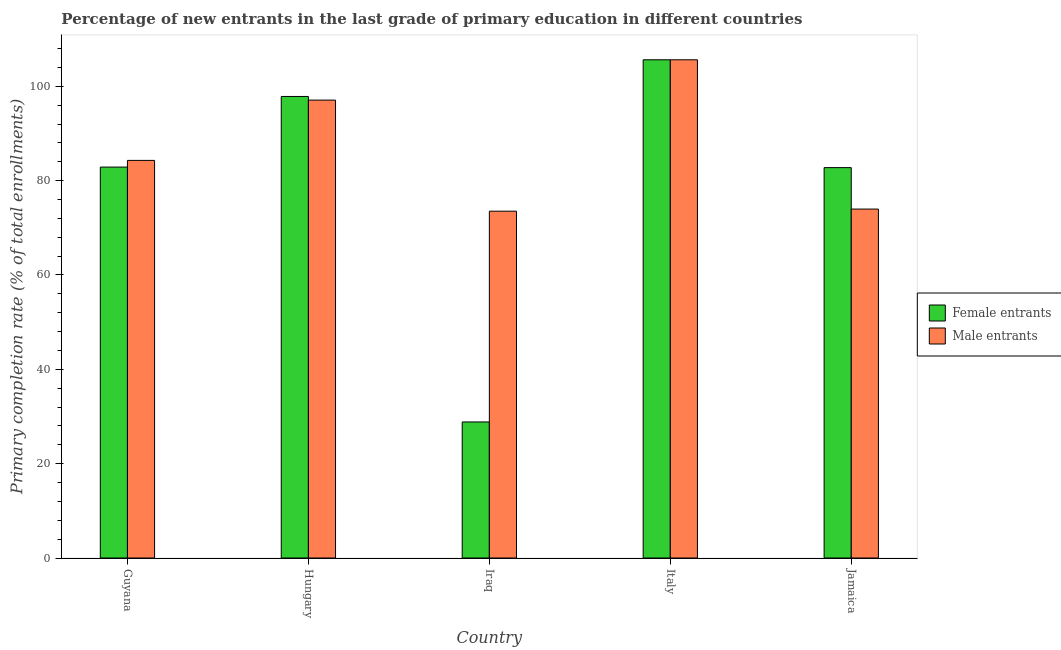How many different coloured bars are there?
Offer a terse response. 2. How many groups of bars are there?
Ensure brevity in your answer.  5. Are the number of bars per tick equal to the number of legend labels?
Offer a very short reply. Yes. Are the number of bars on each tick of the X-axis equal?
Provide a succinct answer. Yes. How many bars are there on the 5th tick from the left?
Make the answer very short. 2. How many bars are there on the 1st tick from the right?
Ensure brevity in your answer.  2. What is the label of the 3rd group of bars from the left?
Provide a succinct answer. Iraq. What is the primary completion rate of male entrants in Hungary?
Your answer should be very brief. 97.07. Across all countries, what is the maximum primary completion rate of male entrants?
Your answer should be very brief. 105.61. Across all countries, what is the minimum primary completion rate of female entrants?
Offer a very short reply. 28.84. In which country was the primary completion rate of female entrants maximum?
Your answer should be very brief. Italy. In which country was the primary completion rate of male entrants minimum?
Keep it short and to the point. Iraq. What is the total primary completion rate of female entrants in the graph?
Your answer should be compact. 397.92. What is the difference between the primary completion rate of female entrants in Hungary and that in Iraq?
Provide a succinct answer. 69. What is the difference between the primary completion rate of female entrants in Hungary and the primary completion rate of male entrants in Jamaica?
Keep it short and to the point. 23.87. What is the average primary completion rate of male entrants per country?
Provide a succinct answer. 86.89. What is the difference between the primary completion rate of male entrants and primary completion rate of female entrants in Hungary?
Keep it short and to the point. -0.77. What is the ratio of the primary completion rate of female entrants in Iraq to that in Jamaica?
Ensure brevity in your answer.  0.35. Is the primary completion rate of male entrants in Hungary less than that in Iraq?
Ensure brevity in your answer.  No. What is the difference between the highest and the second highest primary completion rate of female entrants?
Offer a terse response. 7.77. What is the difference between the highest and the lowest primary completion rate of female entrants?
Offer a very short reply. 76.78. In how many countries, is the primary completion rate of male entrants greater than the average primary completion rate of male entrants taken over all countries?
Offer a terse response. 2. Is the sum of the primary completion rate of female entrants in Iraq and Jamaica greater than the maximum primary completion rate of male entrants across all countries?
Offer a terse response. Yes. What does the 2nd bar from the left in Jamaica represents?
Give a very brief answer. Male entrants. What does the 1st bar from the right in Hungary represents?
Offer a very short reply. Male entrants. What is the difference between two consecutive major ticks on the Y-axis?
Offer a terse response. 20. Are the values on the major ticks of Y-axis written in scientific E-notation?
Offer a terse response. No. Does the graph contain any zero values?
Your answer should be very brief. No. Does the graph contain grids?
Offer a terse response. No. How are the legend labels stacked?
Offer a very short reply. Vertical. What is the title of the graph?
Your answer should be very brief. Percentage of new entrants in the last grade of primary education in different countries. Does "By country of asylum" appear as one of the legend labels in the graph?
Your response must be concise. No. What is the label or title of the X-axis?
Provide a short and direct response. Country. What is the label or title of the Y-axis?
Ensure brevity in your answer.  Primary completion rate (% of total enrollments). What is the Primary completion rate (% of total enrollments) of Female entrants in Guyana?
Provide a succinct answer. 82.87. What is the Primary completion rate (% of total enrollments) in Male entrants in Guyana?
Ensure brevity in your answer.  84.29. What is the Primary completion rate (% of total enrollments) of Female entrants in Hungary?
Make the answer very short. 97.84. What is the Primary completion rate (% of total enrollments) of Male entrants in Hungary?
Provide a succinct answer. 97.07. What is the Primary completion rate (% of total enrollments) of Female entrants in Iraq?
Offer a very short reply. 28.84. What is the Primary completion rate (% of total enrollments) in Male entrants in Iraq?
Offer a terse response. 73.52. What is the Primary completion rate (% of total enrollments) in Female entrants in Italy?
Your answer should be compact. 105.61. What is the Primary completion rate (% of total enrollments) of Male entrants in Italy?
Provide a short and direct response. 105.61. What is the Primary completion rate (% of total enrollments) of Female entrants in Jamaica?
Provide a short and direct response. 82.76. What is the Primary completion rate (% of total enrollments) of Male entrants in Jamaica?
Make the answer very short. 73.97. Across all countries, what is the maximum Primary completion rate (% of total enrollments) of Female entrants?
Your response must be concise. 105.61. Across all countries, what is the maximum Primary completion rate (% of total enrollments) of Male entrants?
Give a very brief answer. 105.61. Across all countries, what is the minimum Primary completion rate (% of total enrollments) of Female entrants?
Give a very brief answer. 28.84. Across all countries, what is the minimum Primary completion rate (% of total enrollments) in Male entrants?
Ensure brevity in your answer.  73.52. What is the total Primary completion rate (% of total enrollments) in Female entrants in the graph?
Give a very brief answer. 397.92. What is the total Primary completion rate (% of total enrollments) of Male entrants in the graph?
Make the answer very short. 434.46. What is the difference between the Primary completion rate (% of total enrollments) of Female entrants in Guyana and that in Hungary?
Offer a very short reply. -14.97. What is the difference between the Primary completion rate (% of total enrollments) of Male entrants in Guyana and that in Hungary?
Keep it short and to the point. -12.78. What is the difference between the Primary completion rate (% of total enrollments) in Female entrants in Guyana and that in Iraq?
Your answer should be very brief. 54.03. What is the difference between the Primary completion rate (% of total enrollments) of Male entrants in Guyana and that in Iraq?
Provide a short and direct response. 10.76. What is the difference between the Primary completion rate (% of total enrollments) of Female entrants in Guyana and that in Italy?
Keep it short and to the point. -22.75. What is the difference between the Primary completion rate (% of total enrollments) in Male entrants in Guyana and that in Italy?
Your answer should be compact. -21.33. What is the difference between the Primary completion rate (% of total enrollments) of Female entrants in Guyana and that in Jamaica?
Offer a terse response. 0.11. What is the difference between the Primary completion rate (% of total enrollments) of Male entrants in Guyana and that in Jamaica?
Give a very brief answer. 10.32. What is the difference between the Primary completion rate (% of total enrollments) in Female entrants in Hungary and that in Iraq?
Provide a short and direct response. 69. What is the difference between the Primary completion rate (% of total enrollments) in Male entrants in Hungary and that in Iraq?
Offer a terse response. 23.55. What is the difference between the Primary completion rate (% of total enrollments) of Female entrants in Hungary and that in Italy?
Your answer should be very brief. -7.77. What is the difference between the Primary completion rate (% of total enrollments) in Male entrants in Hungary and that in Italy?
Offer a very short reply. -8.54. What is the difference between the Primary completion rate (% of total enrollments) of Female entrants in Hungary and that in Jamaica?
Your answer should be very brief. 15.09. What is the difference between the Primary completion rate (% of total enrollments) in Male entrants in Hungary and that in Jamaica?
Your response must be concise. 23.1. What is the difference between the Primary completion rate (% of total enrollments) of Female entrants in Iraq and that in Italy?
Give a very brief answer. -76.78. What is the difference between the Primary completion rate (% of total enrollments) in Male entrants in Iraq and that in Italy?
Provide a short and direct response. -32.09. What is the difference between the Primary completion rate (% of total enrollments) in Female entrants in Iraq and that in Jamaica?
Your answer should be very brief. -53.92. What is the difference between the Primary completion rate (% of total enrollments) in Male entrants in Iraq and that in Jamaica?
Provide a short and direct response. -0.45. What is the difference between the Primary completion rate (% of total enrollments) in Female entrants in Italy and that in Jamaica?
Your response must be concise. 22.86. What is the difference between the Primary completion rate (% of total enrollments) of Male entrants in Italy and that in Jamaica?
Offer a terse response. 31.64. What is the difference between the Primary completion rate (% of total enrollments) of Female entrants in Guyana and the Primary completion rate (% of total enrollments) of Male entrants in Hungary?
Make the answer very short. -14.2. What is the difference between the Primary completion rate (% of total enrollments) of Female entrants in Guyana and the Primary completion rate (% of total enrollments) of Male entrants in Iraq?
Offer a very short reply. 9.35. What is the difference between the Primary completion rate (% of total enrollments) in Female entrants in Guyana and the Primary completion rate (% of total enrollments) in Male entrants in Italy?
Provide a succinct answer. -22.74. What is the difference between the Primary completion rate (% of total enrollments) of Female entrants in Guyana and the Primary completion rate (% of total enrollments) of Male entrants in Jamaica?
Your response must be concise. 8.9. What is the difference between the Primary completion rate (% of total enrollments) of Female entrants in Hungary and the Primary completion rate (% of total enrollments) of Male entrants in Iraq?
Offer a very short reply. 24.32. What is the difference between the Primary completion rate (% of total enrollments) in Female entrants in Hungary and the Primary completion rate (% of total enrollments) in Male entrants in Italy?
Ensure brevity in your answer.  -7.77. What is the difference between the Primary completion rate (% of total enrollments) in Female entrants in Hungary and the Primary completion rate (% of total enrollments) in Male entrants in Jamaica?
Make the answer very short. 23.87. What is the difference between the Primary completion rate (% of total enrollments) of Female entrants in Iraq and the Primary completion rate (% of total enrollments) of Male entrants in Italy?
Give a very brief answer. -76.77. What is the difference between the Primary completion rate (% of total enrollments) in Female entrants in Iraq and the Primary completion rate (% of total enrollments) in Male entrants in Jamaica?
Provide a short and direct response. -45.13. What is the difference between the Primary completion rate (% of total enrollments) of Female entrants in Italy and the Primary completion rate (% of total enrollments) of Male entrants in Jamaica?
Provide a succinct answer. 31.65. What is the average Primary completion rate (% of total enrollments) of Female entrants per country?
Offer a terse response. 79.58. What is the average Primary completion rate (% of total enrollments) in Male entrants per country?
Your answer should be very brief. 86.89. What is the difference between the Primary completion rate (% of total enrollments) of Female entrants and Primary completion rate (% of total enrollments) of Male entrants in Guyana?
Your answer should be compact. -1.42. What is the difference between the Primary completion rate (% of total enrollments) of Female entrants and Primary completion rate (% of total enrollments) of Male entrants in Hungary?
Keep it short and to the point. 0.77. What is the difference between the Primary completion rate (% of total enrollments) in Female entrants and Primary completion rate (% of total enrollments) in Male entrants in Iraq?
Your response must be concise. -44.68. What is the difference between the Primary completion rate (% of total enrollments) of Female entrants and Primary completion rate (% of total enrollments) of Male entrants in Italy?
Your answer should be very brief. 0. What is the difference between the Primary completion rate (% of total enrollments) in Female entrants and Primary completion rate (% of total enrollments) in Male entrants in Jamaica?
Provide a short and direct response. 8.79. What is the ratio of the Primary completion rate (% of total enrollments) in Female entrants in Guyana to that in Hungary?
Your answer should be very brief. 0.85. What is the ratio of the Primary completion rate (% of total enrollments) of Male entrants in Guyana to that in Hungary?
Offer a terse response. 0.87. What is the ratio of the Primary completion rate (% of total enrollments) in Female entrants in Guyana to that in Iraq?
Provide a succinct answer. 2.87. What is the ratio of the Primary completion rate (% of total enrollments) of Male entrants in Guyana to that in Iraq?
Give a very brief answer. 1.15. What is the ratio of the Primary completion rate (% of total enrollments) in Female entrants in Guyana to that in Italy?
Give a very brief answer. 0.78. What is the ratio of the Primary completion rate (% of total enrollments) of Male entrants in Guyana to that in Italy?
Your response must be concise. 0.8. What is the ratio of the Primary completion rate (% of total enrollments) of Female entrants in Guyana to that in Jamaica?
Provide a succinct answer. 1. What is the ratio of the Primary completion rate (% of total enrollments) in Male entrants in Guyana to that in Jamaica?
Give a very brief answer. 1.14. What is the ratio of the Primary completion rate (% of total enrollments) in Female entrants in Hungary to that in Iraq?
Your answer should be very brief. 3.39. What is the ratio of the Primary completion rate (% of total enrollments) of Male entrants in Hungary to that in Iraq?
Offer a very short reply. 1.32. What is the ratio of the Primary completion rate (% of total enrollments) in Female entrants in Hungary to that in Italy?
Your answer should be compact. 0.93. What is the ratio of the Primary completion rate (% of total enrollments) in Male entrants in Hungary to that in Italy?
Keep it short and to the point. 0.92. What is the ratio of the Primary completion rate (% of total enrollments) of Female entrants in Hungary to that in Jamaica?
Provide a short and direct response. 1.18. What is the ratio of the Primary completion rate (% of total enrollments) of Male entrants in Hungary to that in Jamaica?
Offer a very short reply. 1.31. What is the ratio of the Primary completion rate (% of total enrollments) of Female entrants in Iraq to that in Italy?
Offer a terse response. 0.27. What is the ratio of the Primary completion rate (% of total enrollments) of Male entrants in Iraq to that in Italy?
Your answer should be compact. 0.7. What is the ratio of the Primary completion rate (% of total enrollments) in Female entrants in Iraq to that in Jamaica?
Give a very brief answer. 0.35. What is the ratio of the Primary completion rate (% of total enrollments) of Male entrants in Iraq to that in Jamaica?
Give a very brief answer. 0.99. What is the ratio of the Primary completion rate (% of total enrollments) of Female entrants in Italy to that in Jamaica?
Keep it short and to the point. 1.28. What is the ratio of the Primary completion rate (% of total enrollments) of Male entrants in Italy to that in Jamaica?
Provide a short and direct response. 1.43. What is the difference between the highest and the second highest Primary completion rate (% of total enrollments) of Female entrants?
Make the answer very short. 7.77. What is the difference between the highest and the second highest Primary completion rate (% of total enrollments) in Male entrants?
Your answer should be compact. 8.54. What is the difference between the highest and the lowest Primary completion rate (% of total enrollments) of Female entrants?
Provide a short and direct response. 76.78. What is the difference between the highest and the lowest Primary completion rate (% of total enrollments) of Male entrants?
Provide a succinct answer. 32.09. 